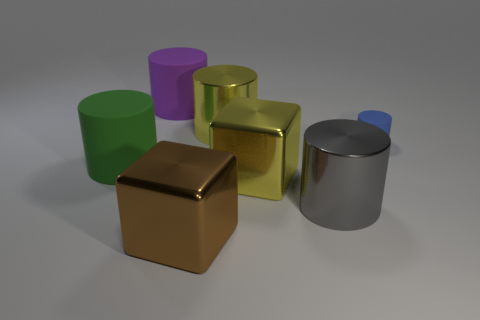Is the material of the large yellow cylinder the same as the blue cylinder?
Ensure brevity in your answer.  No. There is a metallic cylinder on the left side of the large metallic cylinder in front of the cube behind the gray metallic cylinder; how big is it?
Ensure brevity in your answer.  Large. What number of other objects are there of the same color as the tiny cylinder?
Your answer should be compact. 0. What is the shape of the gray shiny object that is the same size as the brown object?
Offer a terse response. Cylinder. What number of big things are either yellow things or blue shiny objects?
Provide a short and direct response. 2. There is a thing in front of the metal cylinder in front of the small blue matte thing; are there any big cylinders that are in front of it?
Make the answer very short. No. Are there any purple things of the same size as the yellow shiny cylinder?
Your answer should be very brief. Yes. There is a purple thing that is the same size as the gray shiny cylinder; what material is it?
Keep it short and to the point. Rubber. Do the brown shiny cube and the thing right of the large gray thing have the same size?
Give a very brief answer. No. How many metal things are big brown blocks or purple cylinders?
Give a very brief answer. 1. 